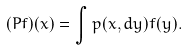Convert formula to latex. <formula><loc_0><loc_0><loc_500><loc_500>( P f ) ( x ) = \int p ( x , d y ) f ( y ) .</formula> 